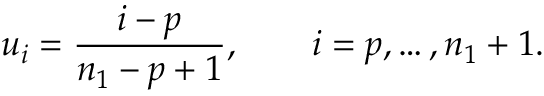<formula> <loc_0><loc_0><loc_500><loc_500>u _ { i } = \frac { i - p } { n _ { 1 } - p + 1 } , \quad i = p , \dots , n _ { 1 } + 1 .</formula> 